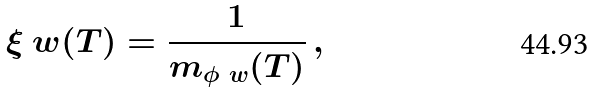Convert formula to latex. <formula><loc_0><loc_0><loc_500><loc_500>\xi _ { \ } w ( T ) = \frac { 1 } { m _ { \phi _ { \ } w } ( T ) } \, ,</formula> 